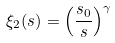<formula> <loc_0><loc_0><loc_500><loc_500>\xi _ { 2 } ( s ) = \left ( \frac { s _ { 0 } } { s } \right ) ^ { \gamma }</formula> 